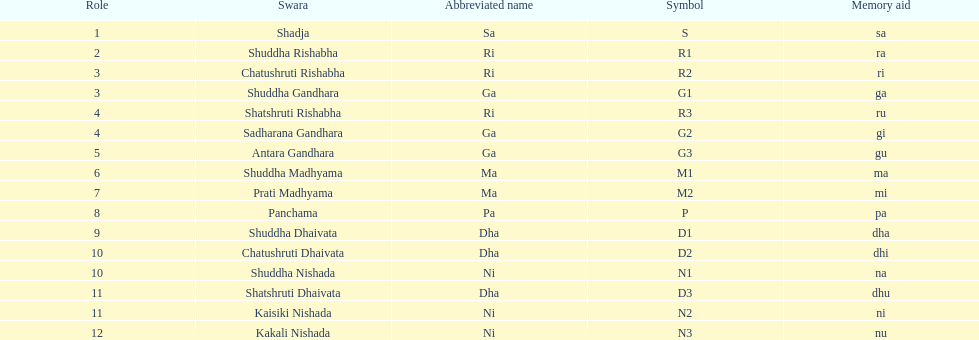In how many swara names does dhaivata not appear? 13. 